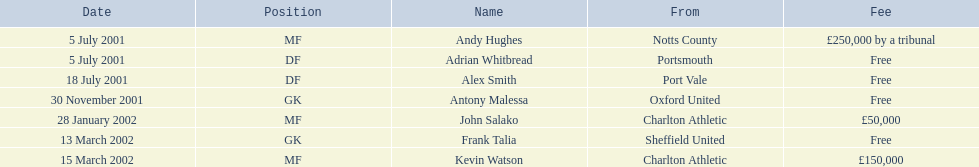Who are all the participants? Andy Hughes, Adrian Whitbread, Alex Smith, Antony Malessa, John Salako, Frank Talia, Kevin Watson. What were their charges? £250,000 by a tribunal, Free, Free, Free, £50,000, Free, £150,000. And how much was kevin watson's charge? £150,000. 